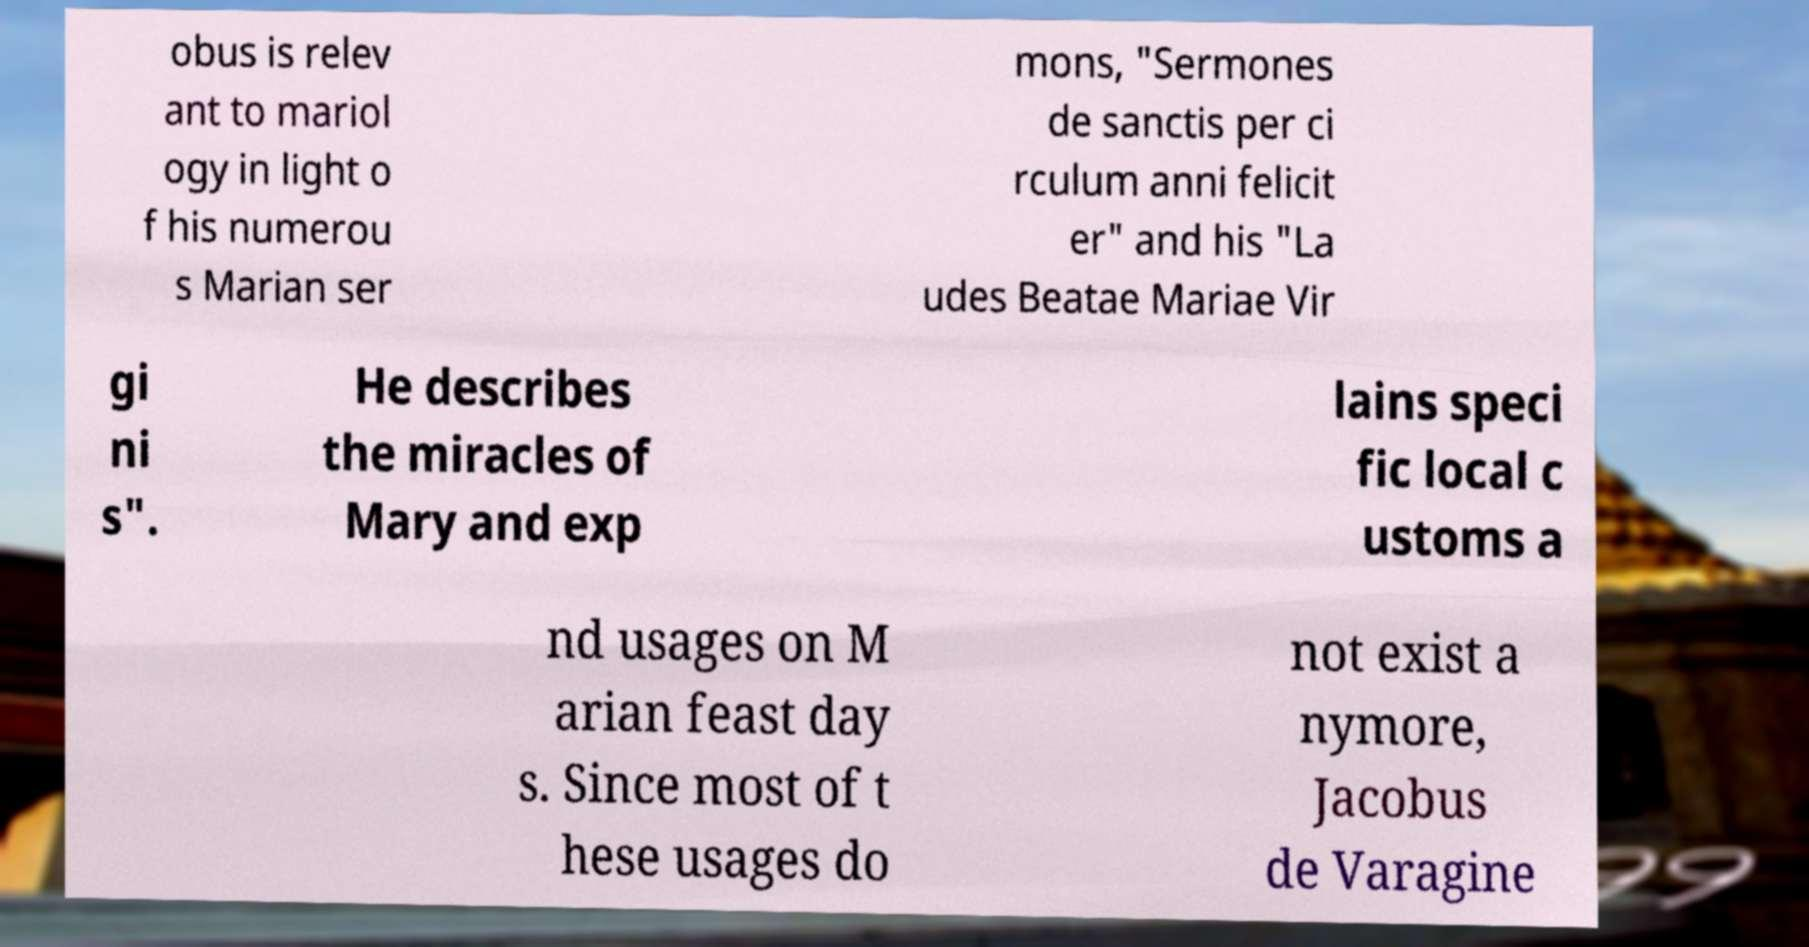Can you read and provide the text displayed in the image?This photo seems to have some interesting text. Can you extract and type it out for me? obus is relev ant to mariol ogy in light o f his numerou s Marian ser mons, "Sermones de sanctis per ci rculum anni felicit er" and his "La udes Beatae Mariae Vir gi ni s". He describes the miracles of Mary and exp lains speci fic local c ustoms a nd usages on M arian feast day s. Since most of t hese usages do not exist a nymore, Jacobus de Varagine 